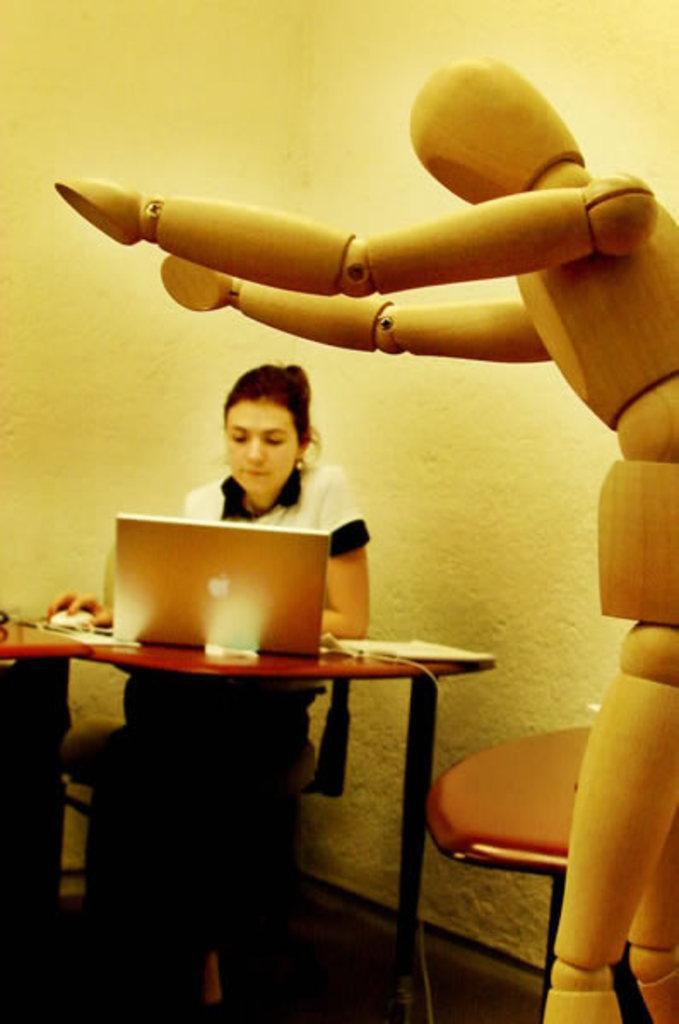How would you summarize this image in a sentence or two? In this picture there is a woman sitting, she is having a table in front of her with the laptop, a mouse and there are some papers, on to the right there is a chair and robot standing here and in the background there is a wall 